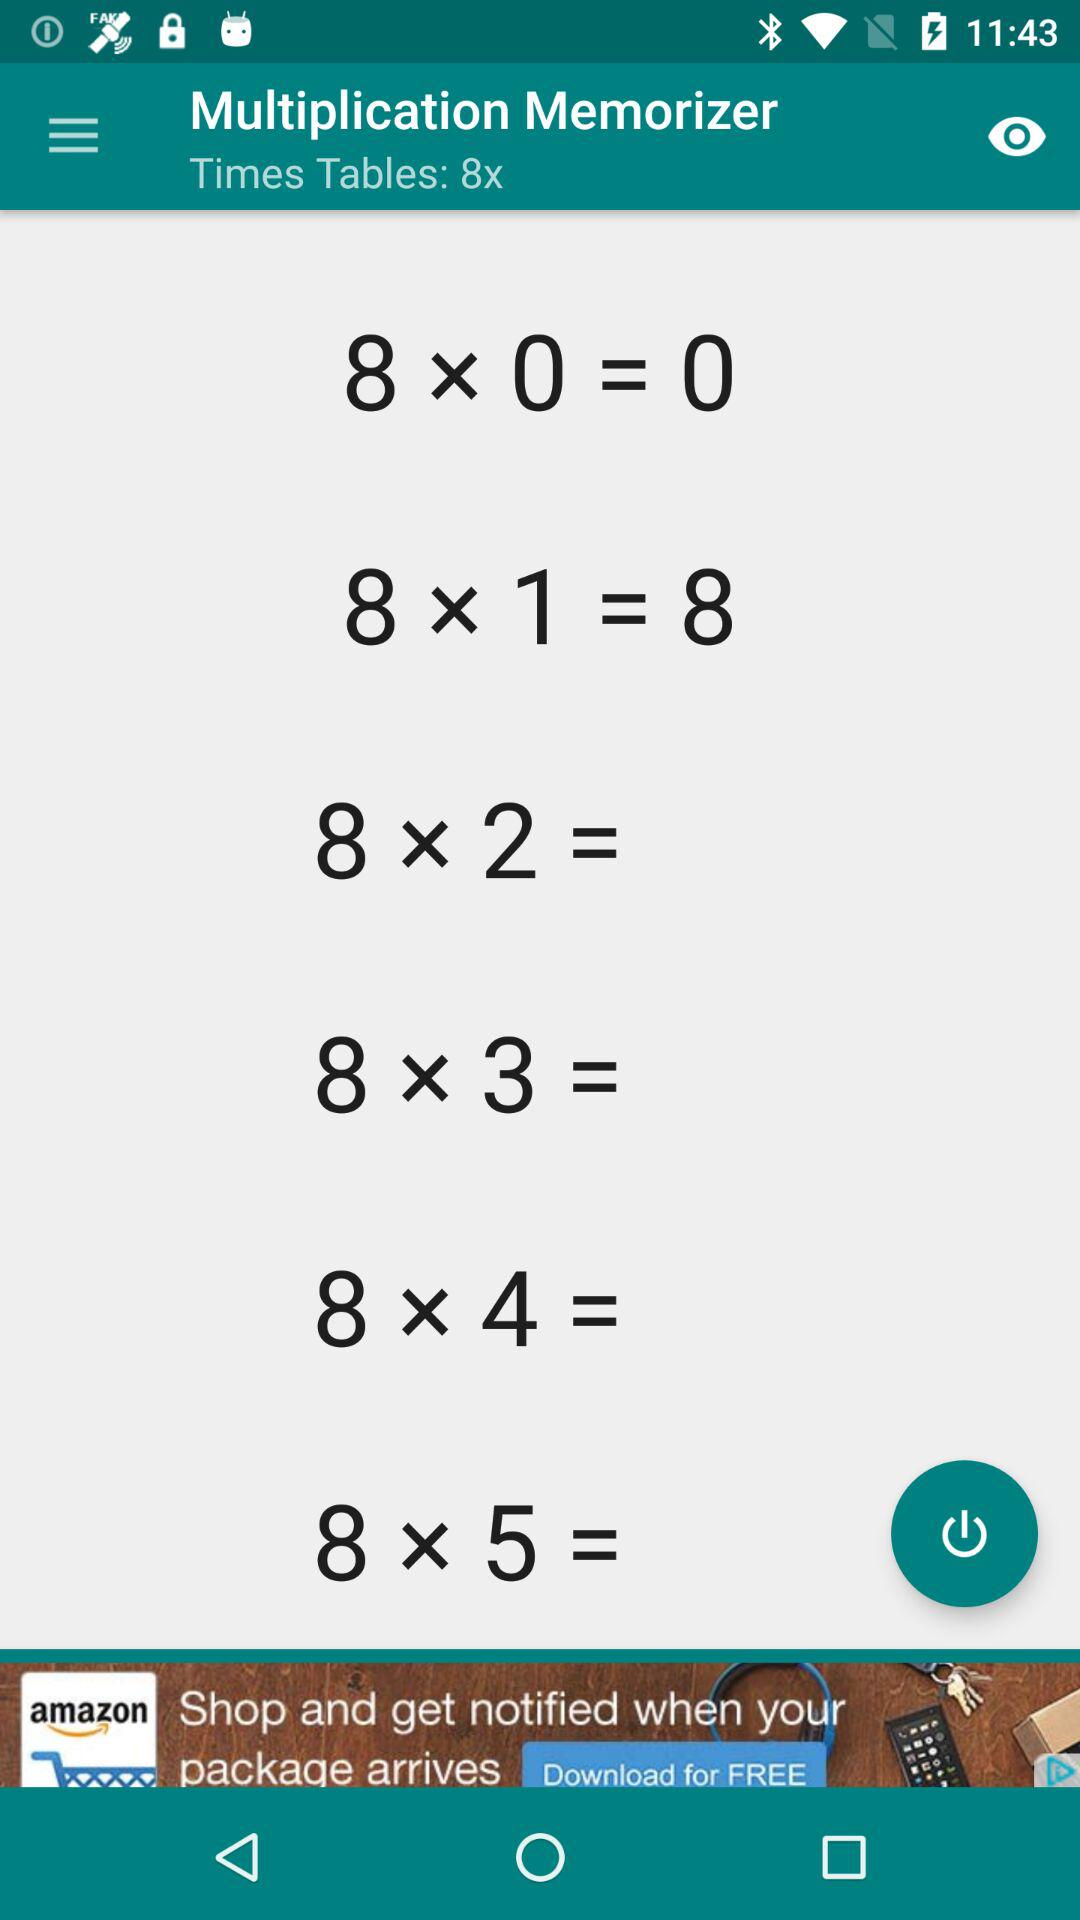What is the output of 8*0? The output is 0. 